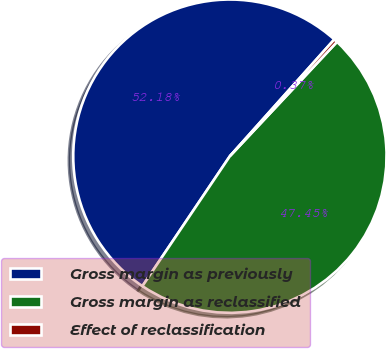Convert chart. <chart><loc_0><loc_0><loc_500><loc_500><pie_chart><fcel>Gross margin as previously<fcel>Gross margin as reclassified<fcel>Effect of reclassification<nl><fcel>52.19%<fcel>47.45%<fcel>0.37%<nl></chart> 